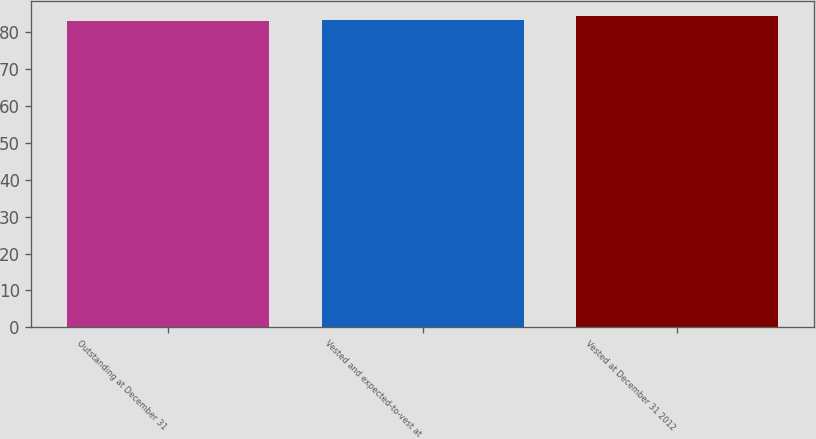Convert chart. <chart><loc_0><loc_0><loc_500><loc_500><bar_chart><fcel>Outstanding at December 31<fcel>Vested and expected-to-vest at<fcel>Vested at December 31 2012<nl><fcel>83.15<fcel>83.27<fcel>84.35<nl></chart> 